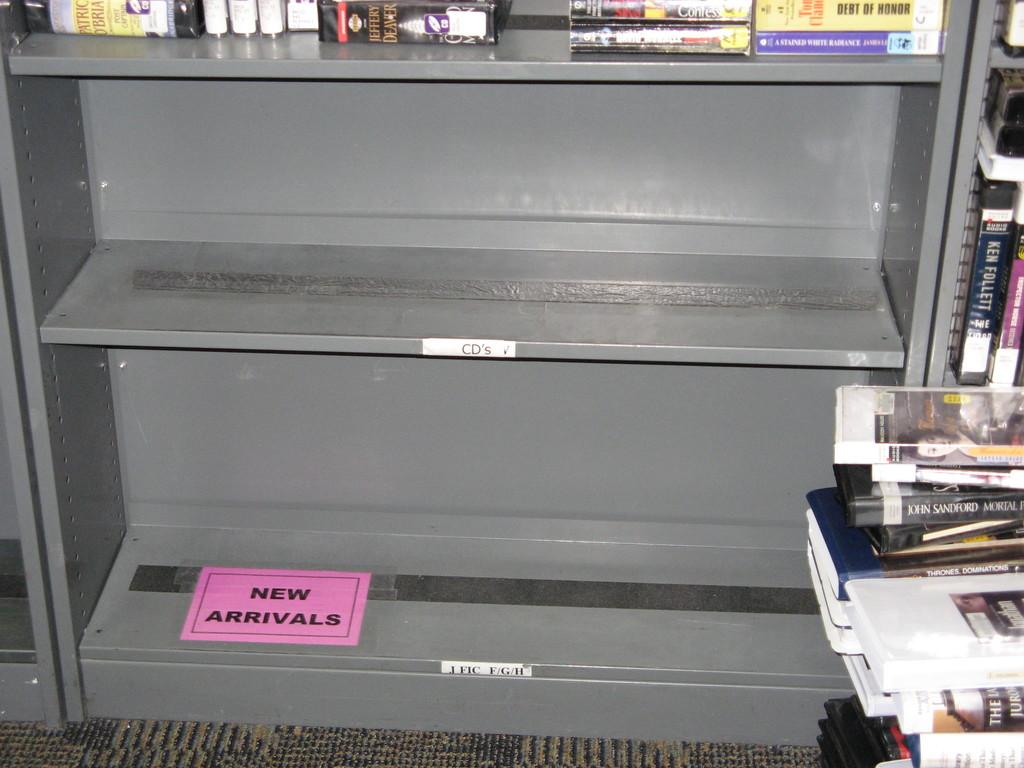What can be seen on the racks in the image? There are racks with books in the image. Where are some of the books located in the image? Some books are kept on the floor in the image. What type of flooring is visible in the image? The floor has a carpet. How many cows are present in the image? There are no cows present in the image; it features racks with books and a carpeted floor. 